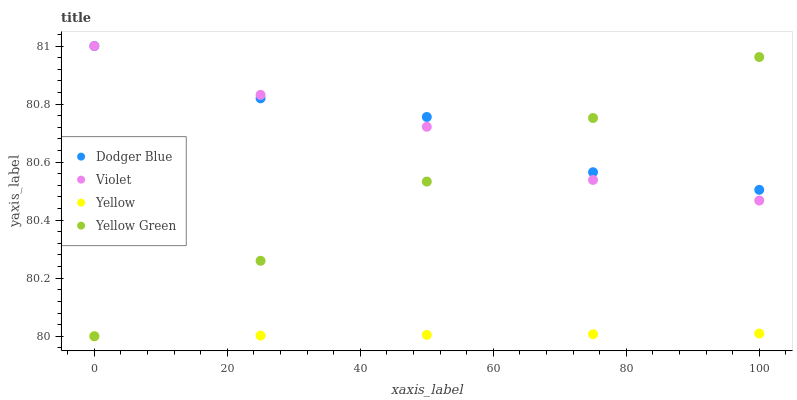Does Yellow have the minimum area under the curve?
Answer yes or no. Yes. Does Dodger Blue have the maximum area under the curve?
Answer yes or no. Yes. Does Yellow Green have the minimum area under the curve?
Answer yes or no. No. Does Yellow Green have the maximum area under the curve?
Answer yes or no. No. Is Yellow the smoothest?
Answer yes or no. Yes. Is Dodger Blue the roughest?
Answer yes or no. Yes. Is Yellow Green the smoothest?
Answer yes or no. No. Is Yellow Green the roughest?
Answer yes or no. No. Does Yellow Green have the lowest value?
Answer yes or no. Yes. Does Violet have the lowest value?
Answer yes or no. No. Does Violet have the highest value?
Answer yes or no. Yes. Does Yellow Green have the highest value?
Answer yes or no. No. Is Yellow less than Violet?
Answer yes or no. Yes. Is Dodger Blue greater than Yellow?
Answer yes or no. Yes. Does Yellow Green intersect Violet?
Answer yes or no. Yes. Is Yellow Green less than Violet?
Answer yes or no. No. Is Yellow Green greater than Violet?
Answer yes or no. No. Does Yellow intersect Violet?
Answer yes or no. No. 